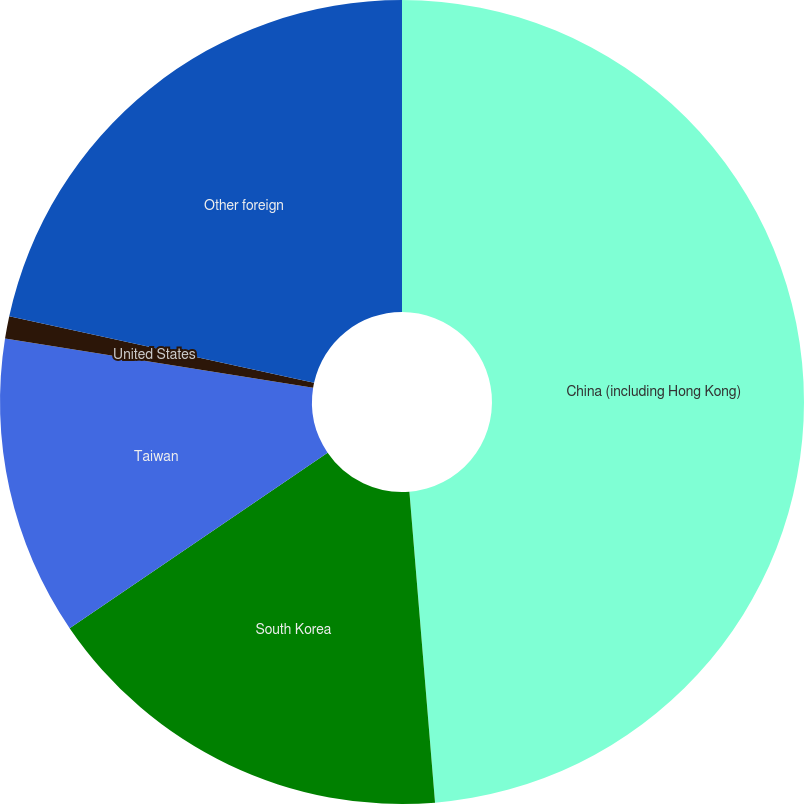Convert chart to OTSL. <chart><loc_0><loc_0><loc_500><loc_500><pie_chart><fcel>China (including Hong Kong)<fcel>South Korea<fcel>Taiwan<fcel>United States<fcel>Other foreign<nl><fcel>48.69%<fcel>16.8%<fcel>12.03%<fcel>0.9%<fcel>21.58%<nl></chart> 